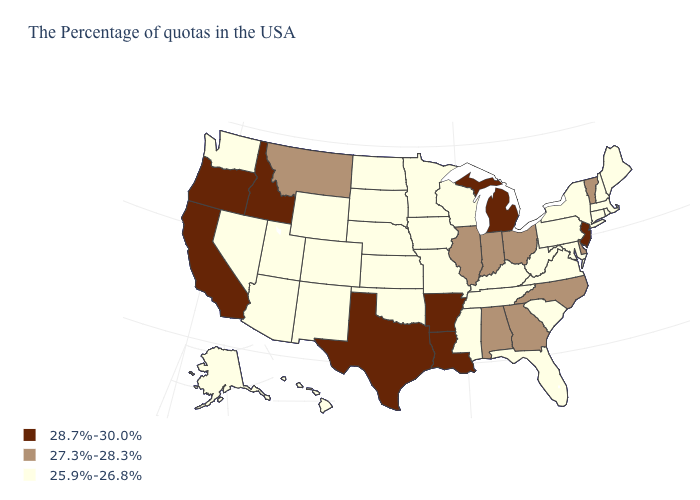Does Utah have the lowest value in the West?
Quick response, please. Yes. Which states have the highest value in the USA?
Concise answer only. New Jersey, Michigan, Louisiana, Arkansas, Texas, Idaho, California, Oregon. Name the states that have a value in the range 28.7%-30.0%?
Write a very short answer. New Jersey, Michigan, Louisiana, Arkansas, Texas, Idaho, California, Oregon. Which states have the highest value in the USA?
Short answer required. New Jersey, Michigan, Louisiana, Arkansas, Texas, Idaho, California, Oregon. What is the highest value in the MidWest ?
Answer briefly. 28.7%-30.0%. What is the value of Hawaii?
Give a very brief answer. 25.9%-26.8%. Does South Dakota have the same value as North Carolina?
Be succinct. No. What is the value of Connecticut?
Quick response, please. 25.9%-26.8%. What is the highest value in the USA?
Concise answer only. 28.7%-30.0%. Does Maine have a lower value than Georgia?
Answer briefly. Yes. Which states have the lowest value in the MidWest?
Answer briefly. Wisconsin, Missouri, Minnesota, Iowa, Kansas, Nebraska, South Dakota, North Dakota. What is the value of Washington?
Short answer required. 25.9%-26.8%. Does Arkansas have the lowest value in the USA?
Short answer required. No. Does the first symbol in the legend represent the smallest category?
Concise answer only. No. Among the states that border Missouri , does Arkansas have the lowest value?
Be succinct. No. 